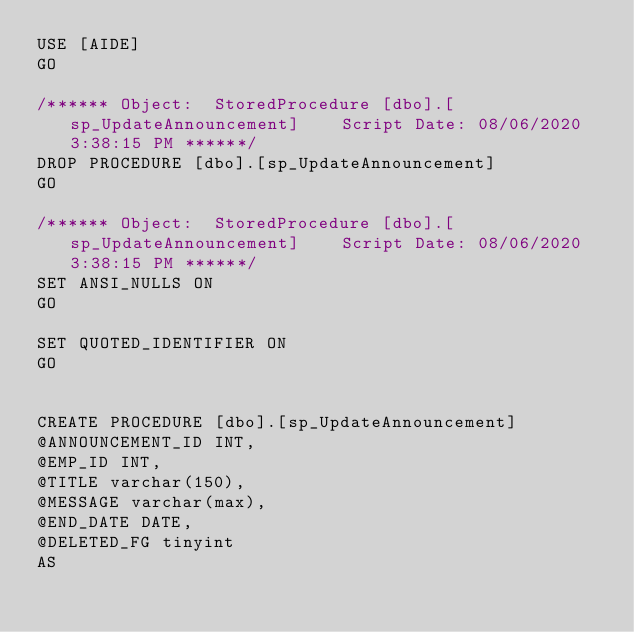Convert code to text. <code><loc_0><loc_0><loc_500><loc_500><_SQL_>USE [AIDE]
GO

/****** Object:  StoredProcedure [dbo].[sp_UpdateAnnouncement]    Script Date: 08/06/2020 3:38:15 PM ******/
DROP PROCEDURE [dbo].[sp_UpdateAnnouncement]
GO

/****** Object:  StoredProcedure [dbo].[sp_UpdateAnnouncement]    Script Date: 08/06/2020 3:38:15 PM ******/
SET ANSI_NULLS ON
GO

SET QUOTED_IDENTIFIER ON
GO


CREATE PROCEDURE [dbo].[sp_UpdateAnnouncement] 
@ANNOUNCEMENT_ID INT, 
@EMP_ID INT, 
@TITLE varchar(150), 
@MESSAGE varchar(max), 
@END_DATE DATE,
@DELETED_FG tinyint
AS</code> 